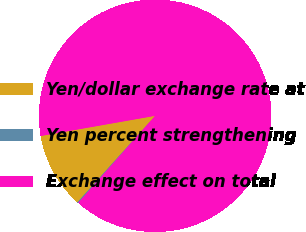<chart> <loc_0><loc_0><loc_500><loc_500><pie_chart><fcel>Yen/dollar exchange rate at<fcel>Yen percent strengthening<fcel>Exchange effect on total<nl><fcel>10.57%<fcel>0.14%<fcel>89.29%<nl></chart> 